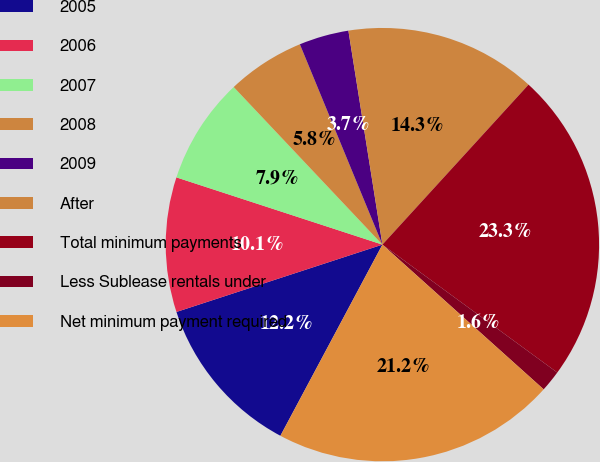Convert chart. <chart><loc_0><loc_0><loc_500><loc_500><pie_chart><fcel>2005<fcel>2006<fcel>2007<fcel>2008<fcel>2009<fcel>After<fcel>Total minimum payments<fcel>Less Sublease rentals under<fcel>Net minimum payment required<nl><fcel>12.17%<fcel>10.05%<fcel>7.94%<fcel>5.82%<fcel>3.71%<fcel>14.29%<fcel>23.27%<fcel>1.59%<fcel>21.16%<nl></chart> 